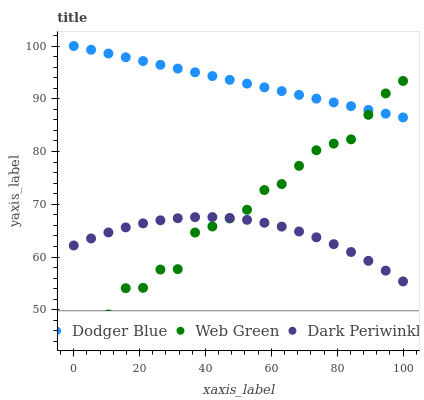Does Dark Periwinkle have the minimum area under the curve?
Answer yes or no. Yes. Does Dodger Blue have the maximum area under the curve?
Answer yes or no. Yes. Does Web Green have the minimum area under the curve?
Answer yes or no. No. Does Web Green have the maximum area under the curve?
Answer yes or no. No. Is Dodger Blue the smoothest?
Answer yes or no. Yes. Is Web Green the roughest?
Answer yes or no. Yes. Is Dark Periwinkle the smoothest?
Answer yes or no. No. Is Dark Periwinkle the roughest?
Answer yes or no. No. Does Web Green have the lowest value?
Answer yes or no. Yes. Does Dark Periwinkle have the lowest value?
Answer yes or no. No. Does Dodger Blue have the highest value?
Answer yes or no. Yes. Does Web Green have the highest value?
Answer yes or no. No. Is Dark Periwinkle less than Dodger Blue?
Answer yes or no. Yes. Is Dodger Blue greater than Dark Periwinkle?
Answer yes or no. Yes. Does Web Green intersect Dark Periwinkle?
Answer yes or no. Yes. Is Web Green less than Dark Periwinkle?
Answer yes or no. No. Is Web Green greater than Dark Periwinkle?
Answer yes or no. No. Does Dark Periwinkle intersect Dodger Blue?
Answer yes or no. No. 